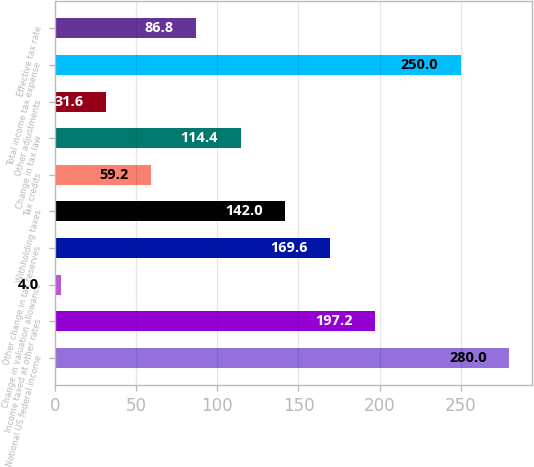Convert chart. <chart><loc_0><loc_0><loc_500><loc_500><bar_chart><fcel>Notional US federal income<fcel>Income taxed at other rates<fcel>Change in valuation allowance<fcel>Other change in tax reserves<fcel>Withholding taxes<fcel>Tax credits<fcel>Change in tax law<fcel>Other adjustments<fcel>Total income tax expense<fcel>Effective tax rate<nl><fcel>280<fcel>197.2<fcel>4<fcel>169.6<fcel>142<fcel>59.2<fcel>114.4<fcel>31.6<fcel>250<fcel>86.8<nl></chart> 